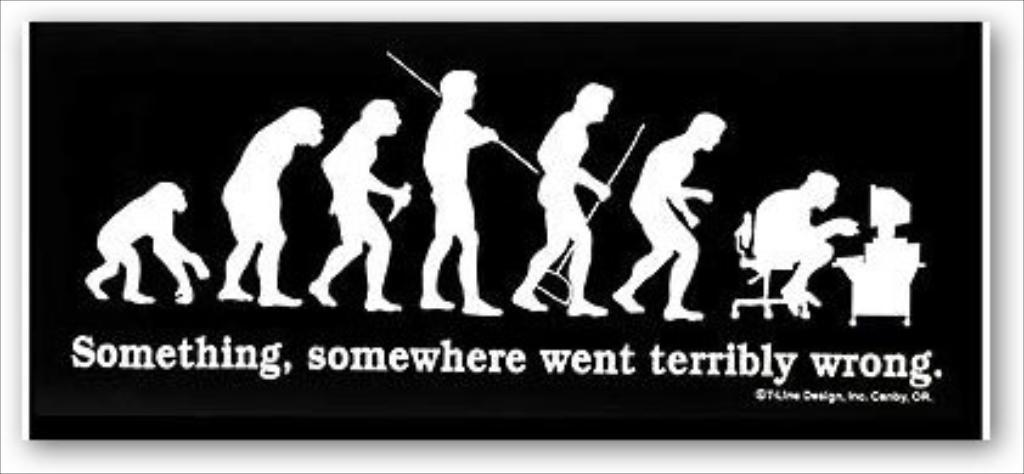What dos this say?
Ensure brevity in your answer.  Something, somewhere went terribly wrong. 